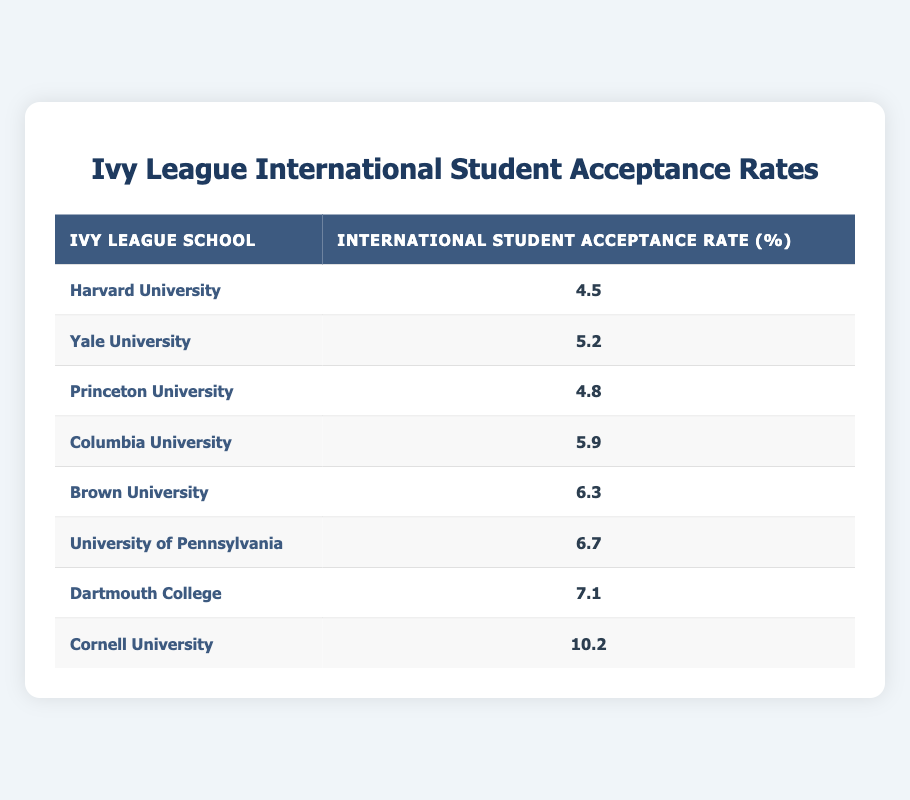What is the acceptance rate for Yale University? The table lists Yale University's acceptance rate as 5.2%, which can be found directly in the corresponding cell under the "International Student Acceptance Rate (%)" column.
Answer: 5.2% Which Ivy League school has the lowest international student acceptance rate? Looking at the values in the table, Harvard University has the lowest acceptance rate at 4.5%, as it is listed first in the "International Student Acceptance Rate (%)" column.
Answer: Harvard University What is the average international student acceptance rate for these schools? To find the average, add all the acceptance rates together (4.5 + 5.2 + 4.8 + 5.9 + 6.3 + 6.7 + 7.1 + 10.2 = 50.7), then divide by the number of schools (50.7 / 8 = 6.3375). Rounding to two decimal places gives an average of 6.34%.
Answer: 6.34% Is it true that Cornell University has a higher acceptance rate than Columbia University? By comparing the two acceptance rates listed, Cornell University has an acceptance rate of 10.2%, while Columbia University has an acceptance rate of 5.9%. Since 10.2 is greater than 5.9, the statement is true.
Answer: Yes What is the difference in acceptance rates between the highest and lowest Ivy League schools? From the table, the highest acceptance rate is for Cornell University at 10.2% and the lowest is for Harvard University at 4.5%. The difference is calculated by subtracting the lowest from the highest (10.2 - 4.5 = 5.7).
Answer: 5.7% 